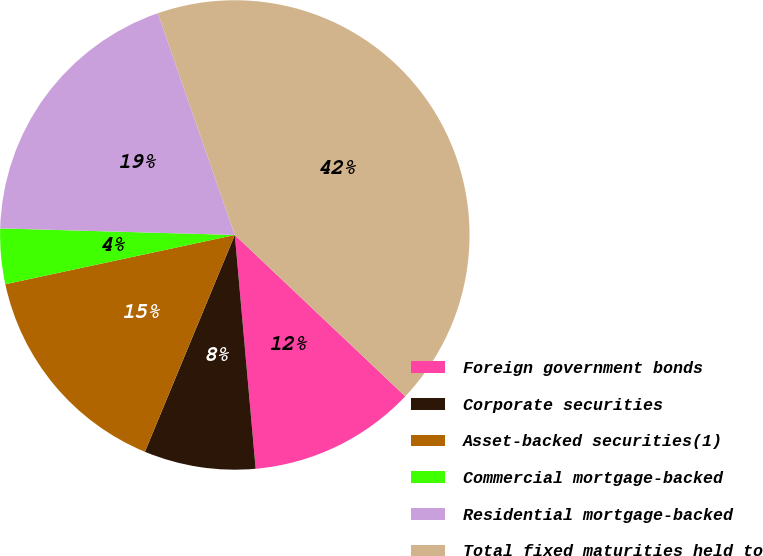<chart> <loc_0><loc_0><loc_500><loc_500><pie_chart><fcel>Foreign government bonds<fcel>Corporate securities<fcel>Asset-backed securities(1)<fcel>Commercial mortgage-backed<fcel>Residential mortgage-backed<fcel>Total fixed maturities held to<nl><fcel>11.52%<fcel>7.67%<fcel>15.38%<fcel>3.81%<fcel>19.24%<fcel>42.38%<nl></chart> 